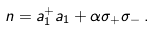<formula> <loc_0><loc_0><loc_500><loc_500>n = a _ { 1 } ^ { + } a _ { 1 } + \alpha \sigma _ { + } \sigma _ { - } \, .</formula> 